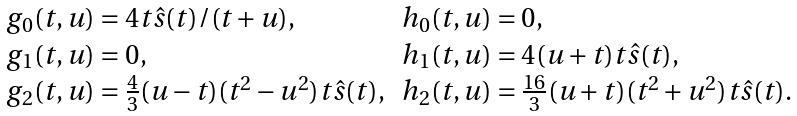<formula> <loc_0><loc_0><loc_500><loc_500>\begin{array} { l l } g _ { 0 } ( t , u ) = 4 t \hat { s } ( t ) / ( t + u ) , & h _ { 0 } ( t , u ) = 0 , \\ g _ { 1 } ( t , u ) = 0 , & h _ { 1 } ( t , u ) = 4 ( u + t ) t \hat { s } ( t ) , \\ g _ { 2 } ( t , u ) = \frac { 4 } { 3 } ( u - t ) ( t ^ { 2 } - u ^ { 2 } ) t \hat { s } ( t ) , & h _ { 2 } ( t , u ) = \frac { 1 6 } { 3 } ( u + t ) ( t ^ { 2 } + u ^ { 2 } ) t \hat { s } ( t ) . \\ \end{array}</formula> 